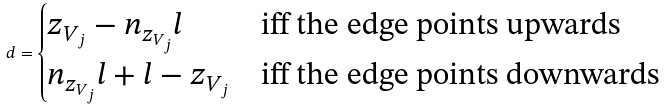Convert formula to latex. <formula><loc_0><loc_0><loc_500><loc_500>d = \begin{cases} z _ { V _ { j } } - n _ { z _ { V _ { j } } } l & \text {iff the edge points upwards} \\ n _ { z _ { V _ { j } } } l + l - z _ { V _ { j } } & \text {iff the edge points downwards} \end{cases}</formula> 